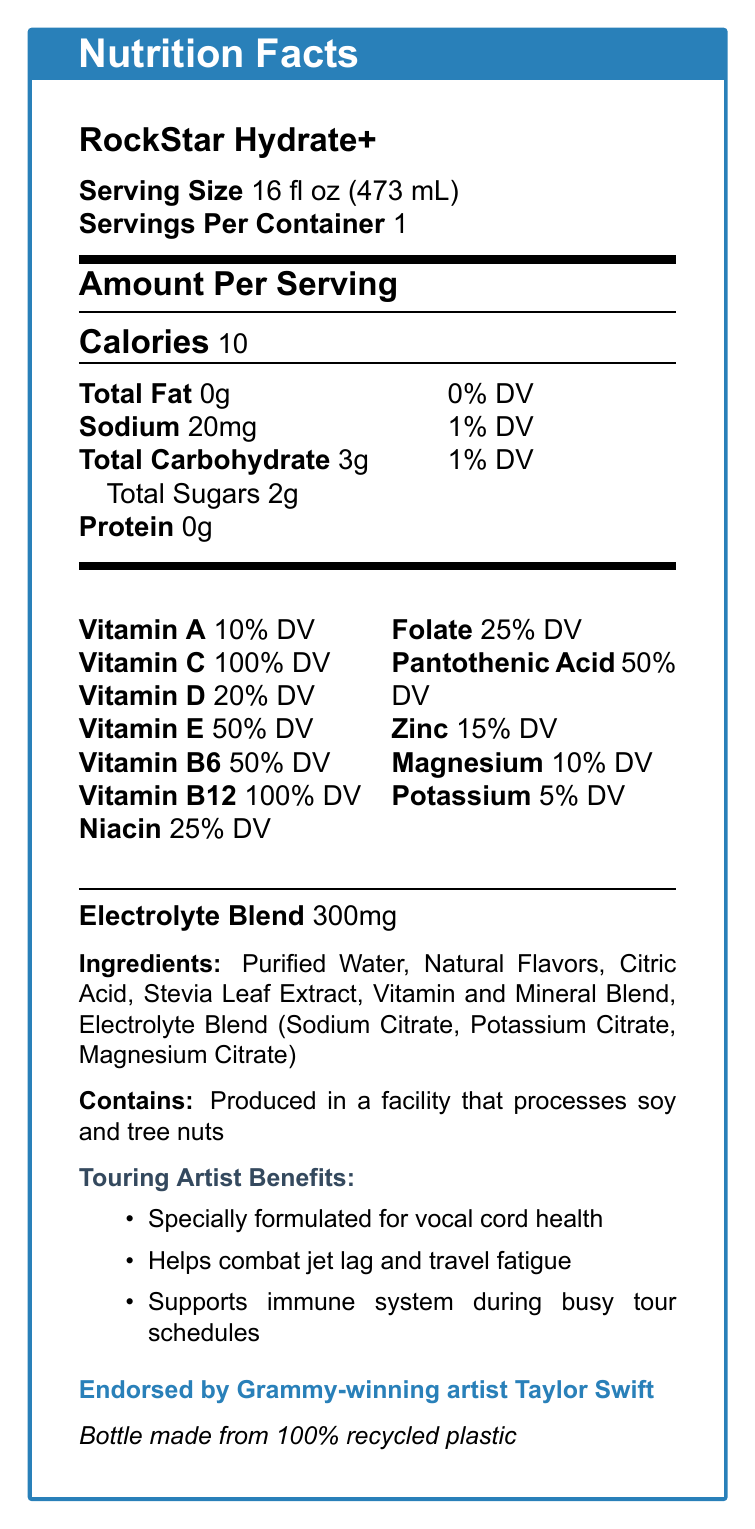what is the serving size of RockStar Hydrate+? This information is stated under the "Serving Size" section in the document.
Answer: 16 fl oz (473 mL) how many calories are in one serving of RockStar Hydrate+? The calories per serving are listed under "Amount Per Serving".
Answer: 10 calories what are the vitamins that cover 100% of the daily value (DV)? The vitamins with 100% DV are explicitly mentioned in the Vitamin section.
Answer: Vitamin C, Vitamin B12 how much sodium does one serving contain? The amount of sodium is listed under "Total Fat" section.
Answer: 20mg how many grams of total sugars are in RockStar Hydrate+? Total sugars are listed under "Total Carbohydrate".
Answer: 2g is RockStar Hydrate+ formulated for vocal cord health? It is stated under "Touring Artist Benefits".
Answer: Yes what is the main idea of the document? The document includes nutrition information, special benefits for artists, and endorsements.
Answer: RockStar Hydrate+ is a vitamin-fortified water designed for touring artists, focusing on hydration, energy, and immune support. what is the amount of potassium included in the drink? The percentage Daily Value for potassium is listed under the vitamins and minerals.
Answer: 5% DV who endorses RockStar Hydrate+? This information is mentioned at the bottom as the brand ambassador.
Answer: Grammy-winning artist Taylor Swift how many grams of protein are in the drink? The protein content is listed as 0g under "Total Fat" section.
Answer: 0g does the document mention if the product is gluten-free? The document does not provide specifics on gluten content.
Answer: Not enough information what facility warning is provided on the document? The allergen information section lists this warning.
Answer: Produced in a facility that processes soy and tree nuts how many grams of total carbohydrates are in RockStar Hydrate+? This is listed under "Total Carbohydrate".
Answer: 3g what materials make up the bottle? This is mentioned under sustainability.
Answer: 100% recycled plastic 